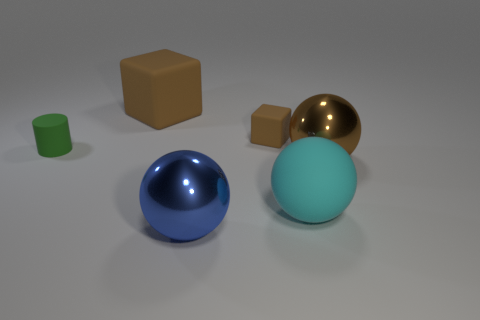Subtract all big matte spheres. How many spheres are left? 2 Add 2 tiny green cylinders. How many objects exist? 8 Subtract all brown balls. How many balls are left? 2 Subtract all tiny objects. Subtract all big blue blocks. How many objects are left? 4 Add 5 shiny things. How many shiny things are left? 7 Add 3 spheres. How many spheres exist? 6 Subtract 1 cyan spheres. How many objects are left? 5 Subtract all cylinders. How many objects are left? 5 Subtract 1 blocks. How many blocks are left? 1 Subtract all yellow balls. Subtract all blue cylinders. How many balls are left? 3 